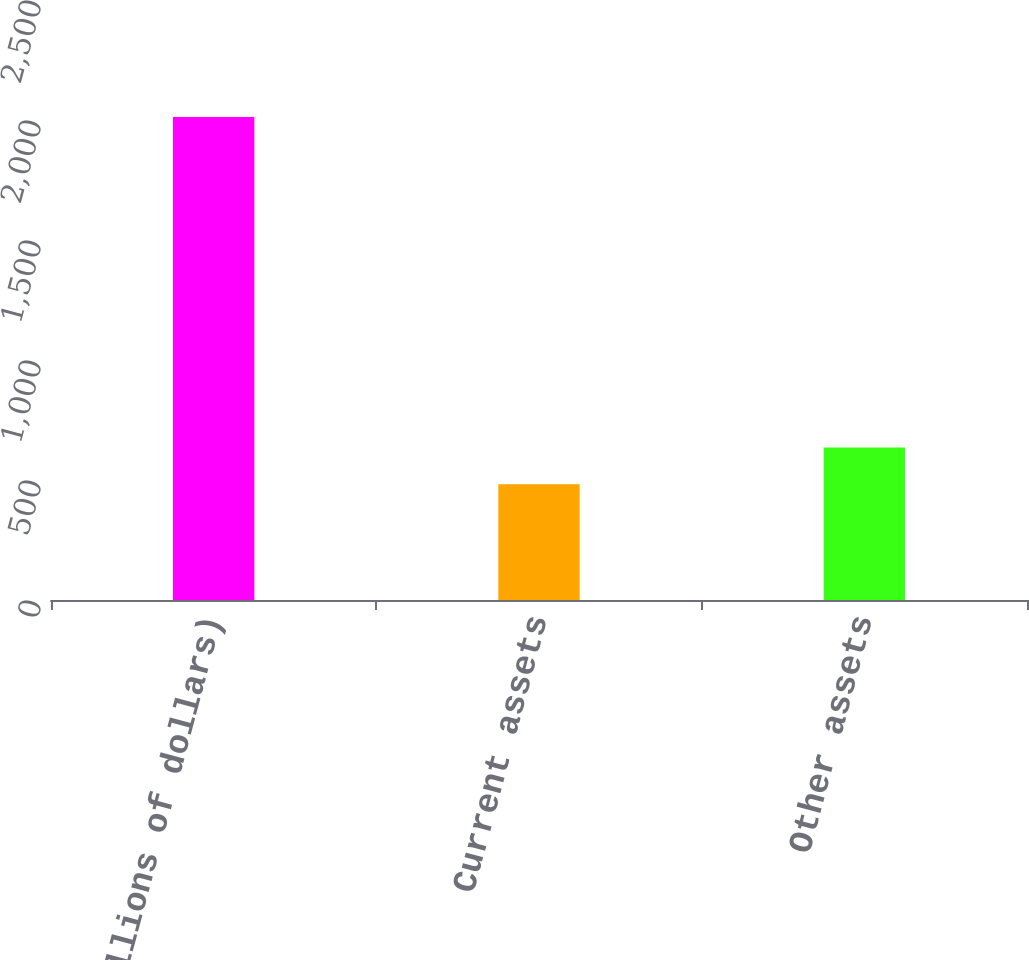<chart> <loc_0><loc_0><loc_500><loc_500><bar_chart><fcel>(In millions of dollars)<fcel>Current assets<fcel>Other assets<nl><fcel>2013<fcel>482<fcel>635.1<nl></chart> 